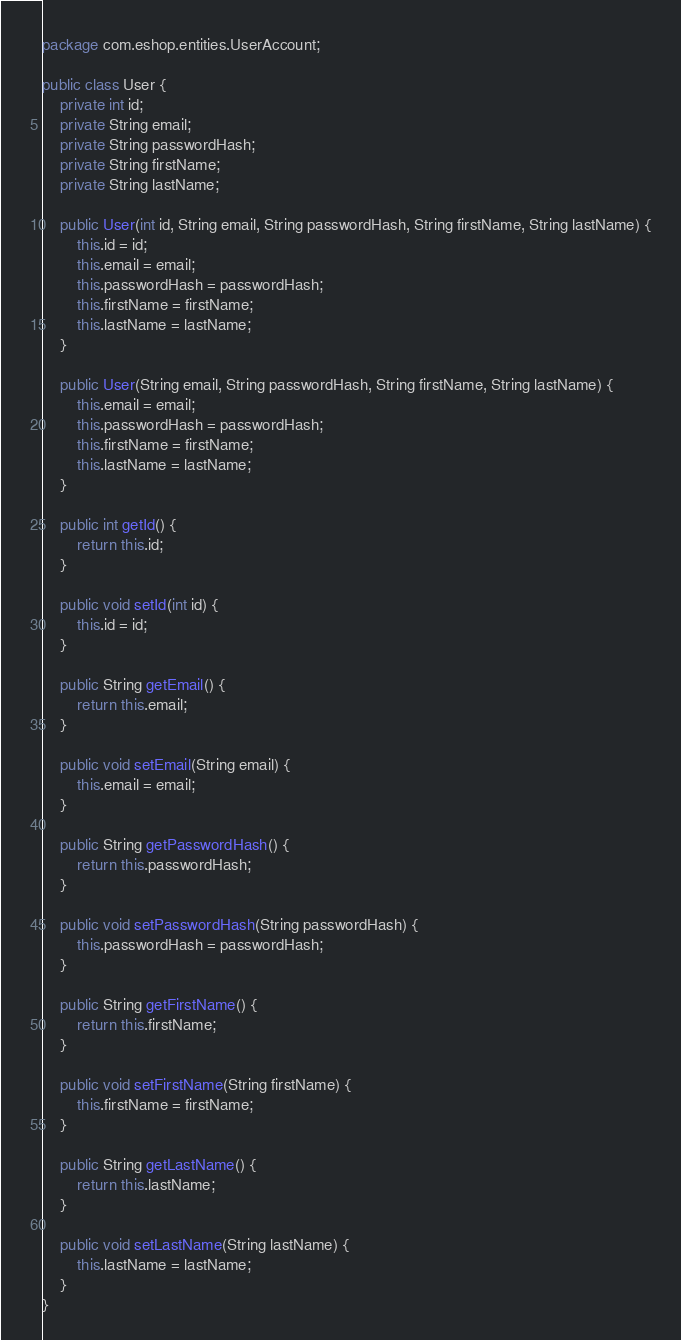Convert code to text. <code><loc_0><loc_0><loc_500><loc_500><_Java_>package com.eshop.entities.UserAccount;

public class User {
    private int id;
    private String email;
    private String passwordHash;
    private String firstName;
    private String lastName;

    public User(int id, String email, String passwordHash, String firstName, String lastName) {
        this.id = id;
        this.email = email;
        this.passwordHash = passwordHash;
        this.firstName = firstName;
        this.lastName = lastName;
    }

    public User(String email, String passwordHash, String firstName, String lastName) {
        this.email = email;
        this.passwordHash = passwordHash;
        this.firstName = firstName;
        this.lastName = lastName;
    }

    public int getId() {
        return this.id;
    }

    public void setId(int id) {
        this.id = id;
    }

    public String getEmail() {
        return this.email;
    }

    public void setEmail(String email) {
        this.email = email;
    }

    public String getPasswordHash() {
        return this.passwordHash;
    }

    public void setPasswordHash(String passwordHash) {
        this.passwordHash = passwordHash;
    }

    public String getFirstName() {
        return this.firstName;
    }

    public void setFirstName(String firstName) {
        this.firstName = firstName;
    }

    public String getLastName() {
        return this.lastName;
    }

    public void setLastName(String lastName) {
        this.lastName = lastName;
    }
}
</code> 